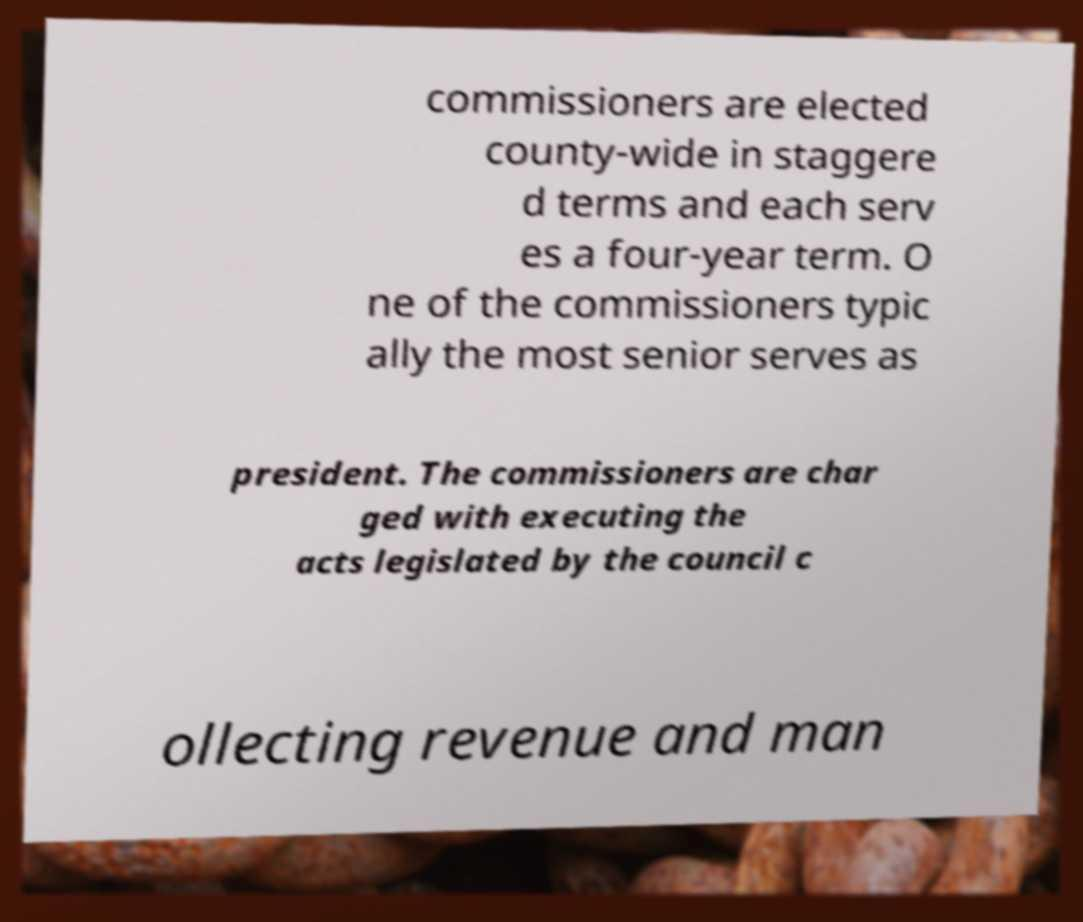Can you accurately transcribe the text from the provided image for me? commissioners are elected county-wide in staggere d terms and each serv es a four-year term. O ne of the commissioners typic ally the most senior serves as president. The commissioners are char ged with executing the acts legislated by the council c ollecting revenue and man 